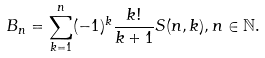Convert formula to latex. <formula><loc_0><loc_0><loc_500><loc_500>B _ { n } = \sum _ { k = 1 } ^ { n } ( - 1 ) ^ { k } \frac { k ! } { k + 1 } S ( n , k ) , n \in \mathbb { N } .</formula> 